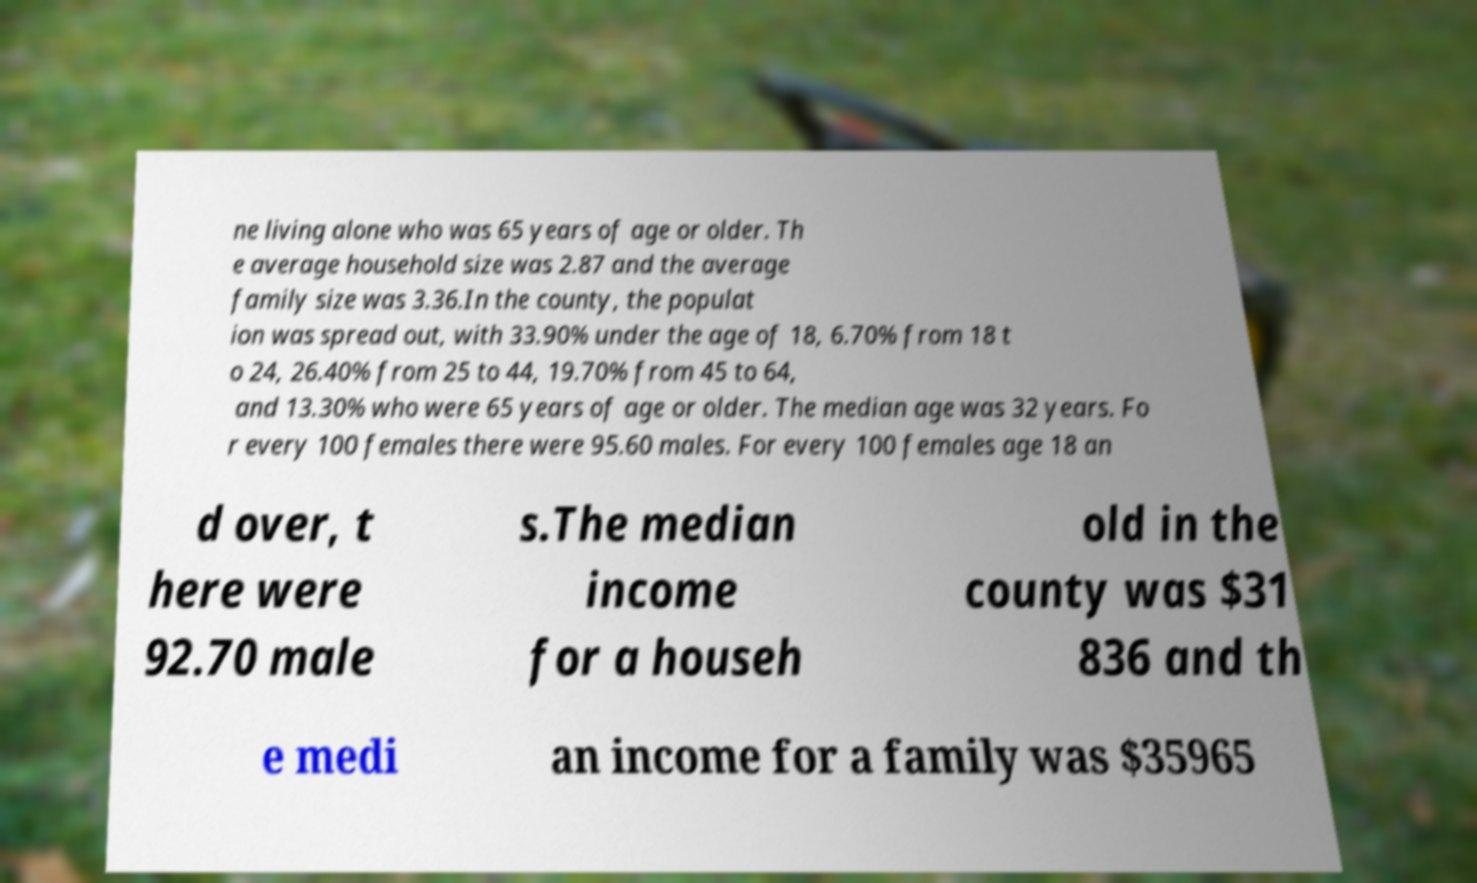Could you assist in decoding the text presented in this image and type it out clearly? ne living alone who was 65 years of age or older. Th e average household size was 2.87 and the average family size was 3.36.In the county, the populat ion was spread out, with 33.90% under the age of 18, 6.70% from 18 t o 24, 26.40% from 25 to 44, 19.70% from 45 to 64, and 13.30% who were 65 years of age or older. The median age was 32 years. Fo r every 100 females there were 95.60 males. For every 100 females age 18 an d over, t here were 92.70 male s.The median income for a househ old in the county was $31 836 and th e medi an income for a family was $35965 